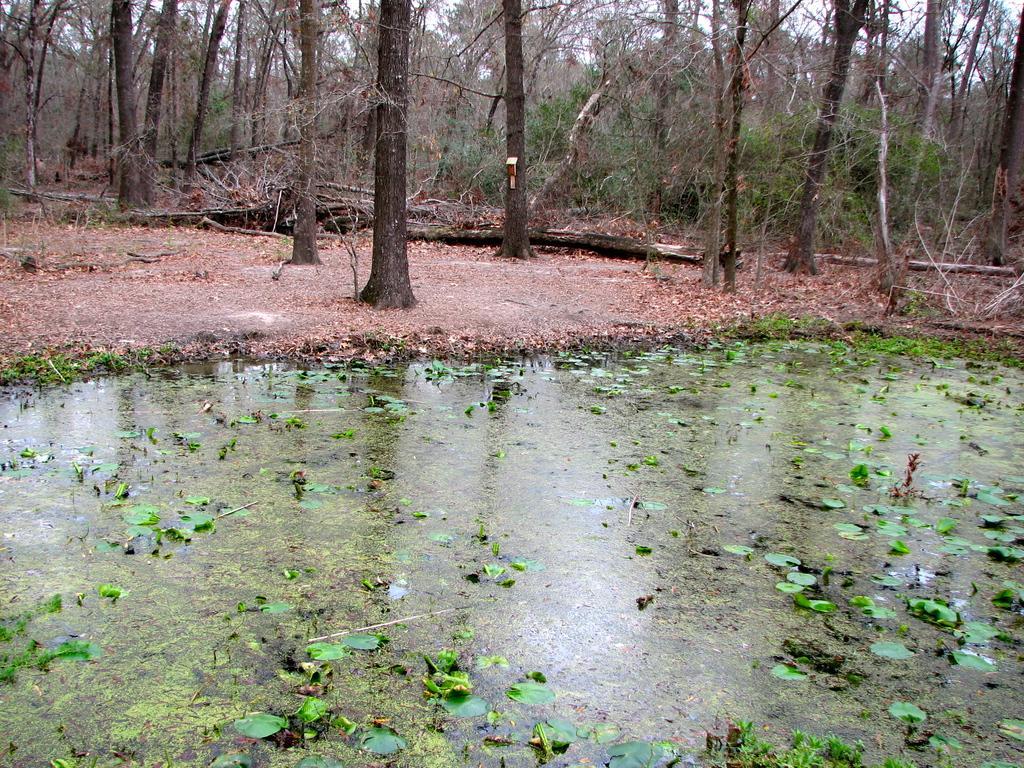In one or two sentences, can you explain what this image depicts? In this picture I can see the many trees. At the bottom I can see the leaves on the water. At the top there is a sky. On the right I can see some tree woods which is fell down. 